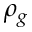Convert formula to latex. <formula><loc_0><loc_0><loc_500><loc_500>\rho _ { g }</formula> 